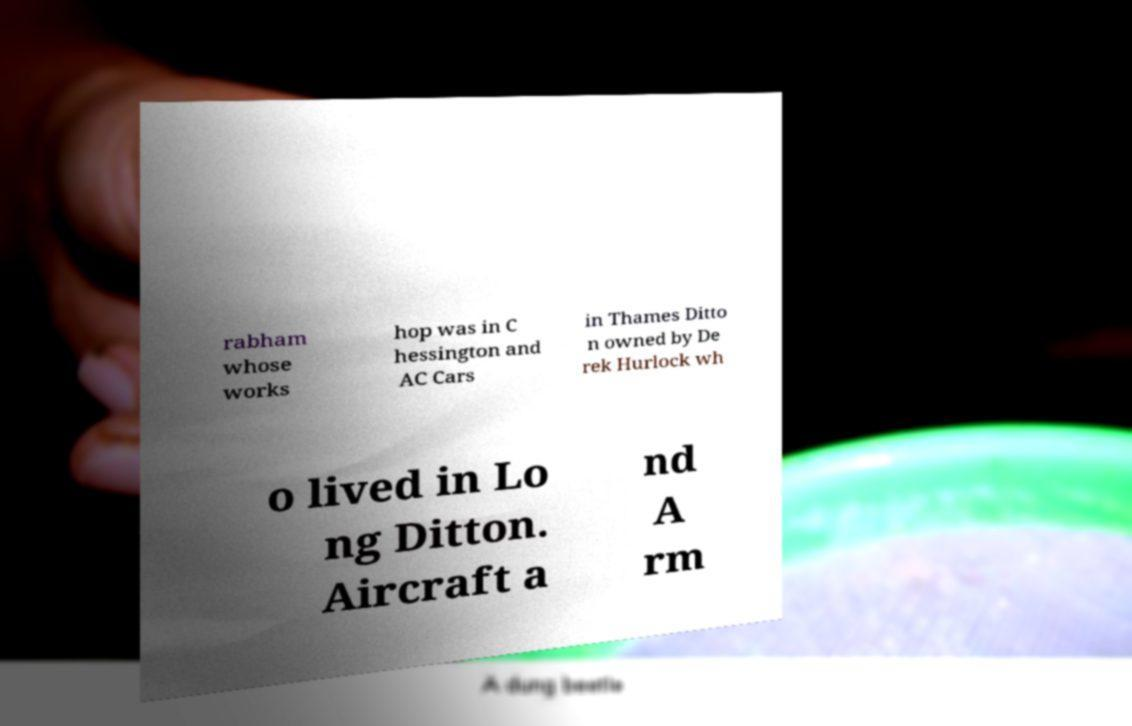I need the written content from this picture converted into text. Can you do that? rabham whose works hop was in C hessington and AC Cars in Thames Ditto n owned by De rek Hurlock wh o lived in Lo ng Ditton. Aircraft a nd A rm 